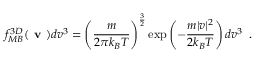Convert formula to latex. <formula><loc_0><loc_0><loc_500><loc_500>f _ { M B } ^ { 3 D } ( v ) d v ^ { 3 } = \left ( \frac { m } { 2 k _ { B } T } \right ) ^ { \frac { 3 } { 2 } } \exp \left ( - \frac { m | v | ^ { 2 } } { 2 k _ { B } T } \right ) d v ^ { 3 } \, .</formula> 